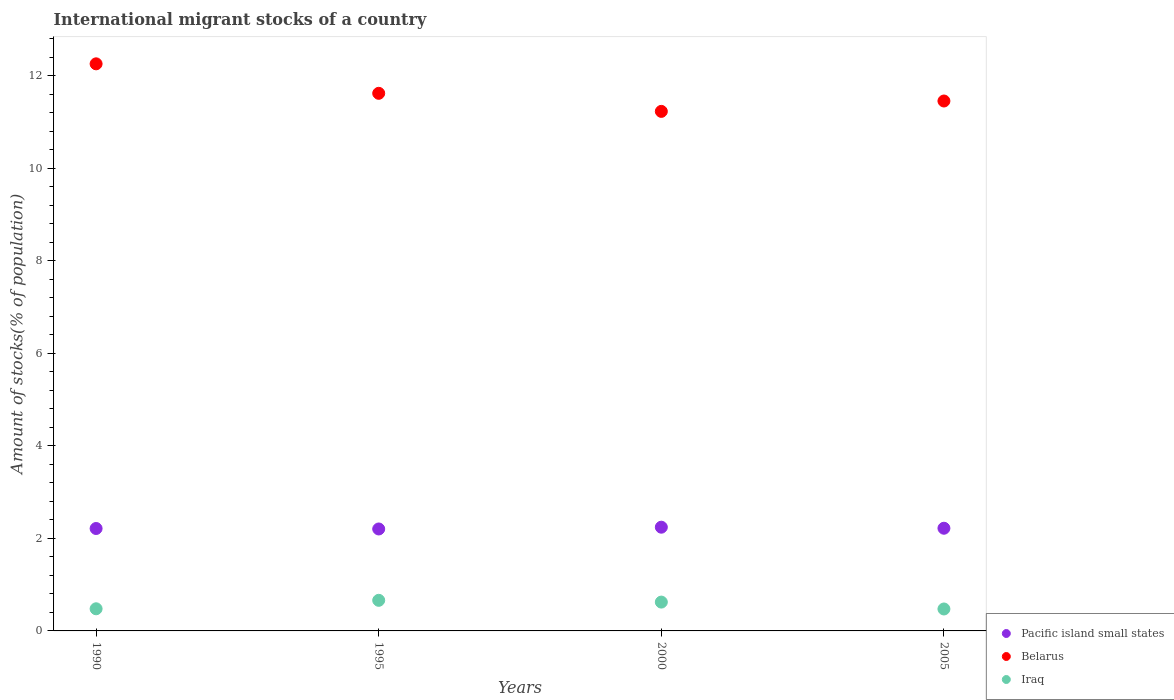Is the number of dotlines equal to the number of legend labels?
Keep it short and to the point. Yes. What is the amount of stocks in in Belarus in 2000?
Provide a short and direct response. 11.23. Across all years, what is the maximum amount of stocks in in Pacific island small states?
Make the answer very short. 2.24. Across all years, what is the minimum amount of stocks in in Iraq?
Give a very brief answer. 0.47. In which year was the amount of stocks in in Iraq maximum?
Ensure brevity in your answer.  1995. What is the total amount of stocks in in Pacific island small states in the graph?
Ensure brevity in your answer.  8.88. What is the difference between the amount of stocks in in Iraq in 1990 and that in 2005?
Your response must be concise. 0. What is the difference between the amount of stocks in in Pacific island small states in 1990 and the amount of stocks in in Iraq in 2005?
Make the answer very short. 1.74. What is the average amount of stocks in in Belarus per year?
Your answer should be compact. 11.64. In the year 2005, what is the difference between the amount of stocks in in Iraq and amount of stocks in in Pacific island small states?
Offer a very short reply. -1.75. What is the ratio of the amount of stocks in in Iraq in 1990 to that in 2000?
Provide a succinct answer. 0.77. Is the difference between the amount of stocks in in Iraq in 1995 and 2005 greater than the difference between the amount of stocks in in Pacific island small states in 1995 and 2005?
Your answer should be very brief. Yes. What is the difference between the highest and the second highest amount of stocks in in Pacific island small states?
Your answer should be compact. 0.02. What is the difference between the highest and the lowest amount of stocks in in Iraq?
Your response must be concise. 0.19. In how many years, is the amount of stocks in in Pacific island small states greater than the average amount of stocks in in Pacific island small states taken over all years?
Provide a short and direct response. 1. Is the amount of stocks in in Belarus strictly less than the amount of stocks in in Pacific island small states over the years?
Provide a succinct answer. No. What is the difference between two consecutive major ticks on the Y-axis?
Ensure brevity in your answer.  2. Does the graph contain any zero values?
Provide a short and direct response. No. How many legend labels are there?
Your answer should be compact. 3. How are the legend labels stacked?
Offer a terse response. Vertical. What is the title of the graph?
Provide a short and direct response. International migrant stocks of a country. Does "Burundi" appear as one of the legend labels in the graph?
Ensure brevity in your answer.  No. What is the label or title of the Y-axis?
Ensure brevity in your answer.  Amount of stocks(% of population). What is the Amount of stocks(% of population) in Pacific island small states in 1990?
Your response must be concise. 2.21. What is the Amount of stocks(% of population) in Belarus in 1990?
Ensure brevity in your answer.  12.26. What is the Amount of stocks(% of population) in Iraq in 1990?
Offer a terse response. 0.48. What is the Amount of stocks(% of population) in Pacific island small states in 1995?
Offer a very short reply. 2.2. What is the Amount of stocks(% of population) in Belarus in 1995?
Offer a terse response. 11.62. What is the Amount of stocks(% of population) of Iraq in 1995?
Give a very brief answer. 0.66. What is the Amount of stocks(% of population) in Pacific island small states in 2000?
Offer a terse response. 2.24. What is the Amount of stocks(% of population) of Belarus in 2000?
Provide a short and direct response. 11.23. What is the Amount of stocks(% of population) in Iraq in 2000?
Your answer should be very brief. 0.62. What is the Amount of stocks(% of population) in Pacific island small states in 2005?
Offer a terse response. 2.22. What is the Amount of stocks(% of population) in Belarus in 2005?
Your response must be concise. 11.45. What is the Amount of stocks(% of population) of Iraq in 2005?
Keep it short and to the point. 0.47. Across all years, what is the maximum Amount of stocks(% of population) of Pacific island small states?
Provide a short and direct response. 2.24. Across all years, what is the maximum Amount of stocks(% of population) of Belarus?
Your response must be concise. 12.26. Across all years, what is the maximum Amount of stocks(% of population) in Iraq?
Provide a succinct answer. 0.66. Across all years, what is the minimum Amount of stocks(% of population) of Pacific island small states?
Offer a very short reply. 2.2. Across all years, what is the minimum Amount of stocks(% of population) in Belarus?
Offer a very short reply. 11.23. Across all years, what is the minimum Amount of stocks(% of population) in Iraq?
Offer a very short reply. 0.47. What is the total Amount of stocks(% of population) of Pacific island small states in the graph?
Ensure brevity in your answer.  8.88. What is the total Amount of stocks(% of population) of Belarus in the graph?
Provide a short and direct response. 46.56. What is the total Amount of stocks(% of population) in Iraq in the graph?
Keep it short and to the point. 2.24. What is the difference between the Amount of stocks(% of population) in Pacific island small states in 1990 and that in 1995?
Offer a terse response. 0.01. What is the difference between the Amount of stocks(% of population) in Belarus in 1990 and that in 1995?
Keep it short and to the point. 0.64. What is the difference between the Amount of stocks(% of population) in Iraq in 1990 and that in 1995?
Provide a short and direct response. -0.18. What is the difference between the Amount of stocks(% of population) in Pacific island small states in 1990 and that in 2000?
Your answer should be very brief. -0.03. What is the difference between the Amount of stocks(% of population) in Belarus in 1990 and that in 2000?
Keep it short and to the point. 1.03. What is the difference between the Amount of stocks(% of population) of Iraq in 1990 and that in 2000?
Your response must be concise. -0.14. What is the difference between the Amount of stocks(% of population) in Pacific island small states in 1990 and that in 2005?
Give a very brief answer. -0.01. What is the difference between the Amount of stocks(% of population) in Belarus in 1990 and that in 2005?
Make the answer very short. 0.8. What is the difference between the Amount of stocks(% of population) of Iraq in 1990 and that in 2005?
Your answer should be very brief. 0. What is the difference between the Amount of stocks(% of population) in Pacific island small states in 1995 and that in 2000?
Keep it short and to the point. -0.04. What is the difference between the Amount of stocks(% of population) of Belarus in 1995 and that in 2000?
Provide a short and direct response. 0.39. What is the difference between the Amount of stocks(% of population) in Iraq in 1995 and that in 2000?
Give a very brief answer. 0.04. What is the difference between the Amount of stocks(% of population) in Pacific island small states in 1995 and that in 2005?
Your answer should be compact. -0.02. What is the difference between the Amount of stocks(% of population) in Belarus in 1995 and that in 2005?
Provide a succinct answer. 0.17. What is the difference between the Amount of stocks(% of population) of Iraq in 1995 and that in 2005?
Keep it short and to the point. 0.19. What is the difference between the Amount of stocks(% of population) of Pacific island small states in 2000 and that in 2005?
Give a very brief answer. 0.02. What is the difference between the Amount of stocks(% of population) in Belarus in 2000 and that in 2005?
Your answer should be very brief. -0.22. What is the difference between the Amount of stocks(% of population) in Iraq in 2000 and that in 2005?
Make the answer very short. 0.15. What is the difference between the Amount of stocks(% of population) in Pacific island small states in 1990 and the Amount of stocks(% of population) in Belarus in 1995?
Your answer should be very brief. -9.41. What is the difference between the Amount of stocks(% of population) of Pacific island small states in 1990 and the Amount of stocks(% of population) of Iraq in 1995?
Provide a succinct answer. 1.55. What is the difference between the Amount of stocks(% of population) in Belarus in 1990 and the Amount of stocks(% of population) in Iraq in 1995?
Provide a succinct answer. 11.6. What is the difference between the Amount of stocks(% of population) of Pacific island small states in 1990 and the Amount of stocks(% of population) of Belarus in 2000?
Give a very brief answer. -9.02. What is the difference between the Amount of stocks(% of population) in Pacific island small states in 1990 and the Amount of stocks(% of population) in Iraq in 2000?
Your response must be concise. 1.59. What is the difference between the Amount of stocks(% of population) in Belarus in 1990 and the Amount of stocks(% of population) in Iraq in 2000?
Ensure brevity in your answer.  11.63. What is the difference between the Amount of stocks(% of population) in Pacific island small states in 1990 and the Amount of stocks(% of population) in Belarus in 2005?
Keep it short and to the point. -9.24. What is the difference between the Amount of stocks(% of population) of Pacific island small states in 1990 and the Amount of stocks(% of population) of Iraq in 2005?
Your answer should be very brief. 1.74. What is the difference between the Amount of stocks(% of population) of Belarus in 1990 and the Amount of stocks(% of population) of Iraq in 2005?
Offer a very short reply. 11.78. What is the difference between the Amount of stocks(% of population) of Pacific island small states in 1995 and the Amount of stocks(% of population) of Belarus in 2000?
Offer a terse response. -9.03. What is the difference between the Amount of stocks(% of population) of Pacific island small states in 1995 and the Amount of stocks(% of population) of Iraq in 2000?
Ensure brevity in your answer.  1.58. What is the difference between the Amount of stocks(% of population) in Belarus in 1995 and the Amount of stocks(% of population) in Iraq in 2000?
Offer a terse response. 11. What is the difference between the Amount of stocks(% of population) of Pacific island small states in 1995 and the Amount of stocks(% of population) of Belarus in 2005?
Your answer should be very brief. -9.25. What is the difference between the Amount of stocks(% of population) in Pacific island small states in 1995 and the Amount of stocks(% of population) in Iraq in 2005?
Provide a short and direct response. 1.73. What is the difference between the Amount of stocks(% of population) in Belarus in 1995 and the Amount of stocks(% of population) in Iraq in 2005?
Offer a very short reply. 11.15. What is the difference between the Amount of stocks(% of population) of Pacific island small states in 2000 and the Amount of stocks(% of population) of Belarus in 2005?
Offer a very short reply. -9.21. What is the difference between the Amount of stocks(% of population) in Pacific island small states in 2000 and the Amount of stocks(% of population) in Iraq in 2005?
Your answer should be very brief. 1.77. What is the difference between the Amount of stocks(% of population) of Belarus in 2000 and the Amount of stocks(% of population) of Iraq in 2005?
Provide a succinct answer. 10.76. What is the average Amount of stocks(% of population) in Pacific island small states per year?
Your answer should be compact. 2.22. What is the average Amount of stocks(% of population) of Belarus per year?
Offer a terse response. 11.64. What is the average Amount of stocks(% of population) of Iraq per year?
Keep it short and to the point. 0.56. In the year 1990, what is the difference between the Amount of stocks(% of population) of Pacific island small states and Amount of stocks(% of population) of Belarus?
Provide a succinct answer. -10.04. In the year 1990, what is the difference between the Amount of stocks(% of population) in Pacific island small states and Amount of stocks(% of population) in Iraq?
Provide a succinct answer. 1.74. In the year 1990, what is the difference between the Amount of stocks(% of population) in Belarus and Amount of stocks(% of population) in Iraq?
Provide a short and direct response. 11.78. In the year 1995, what is the difference between the Amount of stocks(% of population) of Pacific island small states and Amount of stocks(% of population) of Belarus?
Make the answer very short. -9.42. In the year 1995, what is the difference between the Amount of stocks(% of population) of Pacific island small states and Amount of stocks(% of population) of Iraq?
Provide a short and direct response. 1.54. In the year 1995, what is the difference between the Amount of stocks(% of population) of Belarus and Amount of stocks(% of population) of Iraq?
Provide a succinct answer. 10.96. In the year 2000, what is the difference between the Amount of stocks(% of population) in Pacific island small states and Amount of stocks(% of population) in Belarus?
Offer a terse response. -8.99. In the year 2000, what is the difference between the Amount of stocks(% of population) of Pacific island small states and Amount of stocks(% of population) of Iraq?
Offer a terse response. 1.62. In the year 2000, what is the difference between the Amount of stocks(% of population) in Belarus and Amount of stocks(% of population) in Iraq?
Provide a succinct answer. 10.61. In the year 2005, what is the difference between the Amount of stocks(% of population) of Pacific island small states and Amount of stocks(% of population) of Belarus?
Provide a succinct answer. -9.24. In the year 2005, what is the difference between the Amount of stocks(% of population) of Pacific island small states and Amount of stocks(% of population) of Iraq?
Offer a terse response. 1.75. In the year 2005, what is the difference between the Amount of stocks(% of population) in Belarus and Amount of stocks(% of population) in Iraq?
Keep it short and to the point. 10.98. What is the ratio of the Amount of stocks(% of population) of Belarus in 1990 to that in 1995?
Give a very brief answer. 1.05. What is the ratio of the Amount of stocks(% of population) of Iraq in 1990 to that in 1995?
Keep it short and to the point. 0.72. What is the ratio of the Amount of stocks(% of population) of Pacific island small states in 1990 to that in 2000?
Give a very brief answer. 0.99. What is the ratio of the Amount of stocks(% of population) of Belarus in 1990 to that in 2000?
Make the answer very short. 1.09. What is the ratio of the Amount of stocks(% of population) in Iraq in 1990 to that in 2000?
Provide a succinct answer. 0.77. What is the ratio of the Amount of stocks(% of population) of Belarus in 1990 to that in 2005?
Give a very brief answer. 1.07. What is the ratio of the Amount of stocks(% of population) of Iraq in 1990 to that in 2005?
Offer a terse response. 1.01. What is the ratio of the Amount of stocks(% of population) of Pacific island small states in 1995 to that in 2000?
Provide a succinct answer. 0.98. What is the ratio of the Amount of stocks(% of population) of Belarus in 1995 to that in 2000?
Your answer should be compact. 1.03. What is the ratio of the Amount of stocks(% of population) in Iraq in 1995 to that in 2000?
Your answer should be compact. 1.06. What is the ratio of the Amount of stocks(% of population) of Belarus in 1995 to that in 2005?
Make the answer very short. 1.01. What is the ratio of the Amount of stocks(% of population) in Iraq in 1995 to that in 2005?
Your answer should be very brief. 1.39. What is the ratio of the Amount of stocks(% of population) of Pacific island small states in 2000 to that in 2005?
Provide a short and direct response. 1.01. What is the ratio of the Amount of stocks(% of population) of Belarus in 2000 to that in 2005?
Your answer should be very brief. 0.98. What is the ratio of the Amount of stocks(% of population) in Iraq in 2000 to that in 2005?
Offer a terse response. 1.31. What is the difference between the highest and the second highest Amount of stocks(% of population) in Pacific island small states?
Make the answer very short. 0.02. What is the difference between the highest and the second highest Amount of stocks(% of population) of Belarus?
Provide a succinct answer. 0.64. What is the difference between the highest and the second highest Amount of stocks(% of population) in Iraq?
Offer a very short reply. 0.04. What is the difference between the highest and the lowest Amount of stocks(% of population) in Pacific island small states?
Ensure brevity in your answer.  0.04. What is the difference between the highest and the lowest Amount of stocks(% of population) of Belarus?
Your response must be concise. 1.03. What is the difference between the highest and the lowest Amount of stocks(% of population) in Iraq?
Your response must be concise. 0.19. 